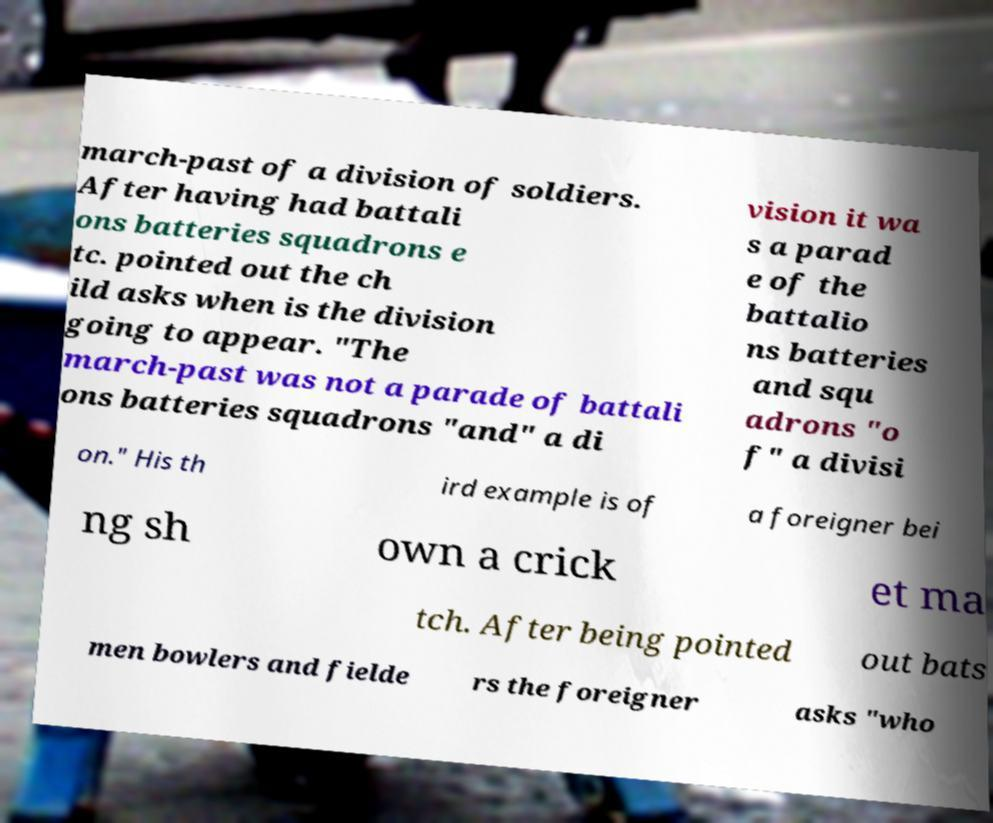Please identify and transcribe the text found in this image. march-past of a division of soldiers. After having had battali ons batteries squadrons e tc. pointed out the ch ild asks when is the division going to appear. "The march-past was not a parade of battali ons batteries squadrons "and" a di vision it wa s a parad e of the battalio ns batteries and squ adrons "o f" a divisi on." His th ird example is of a foreigner bei ng sh own a crick et ma tch. After being pointed out bats men bowlers and fielde rs the foreigner asks "who 